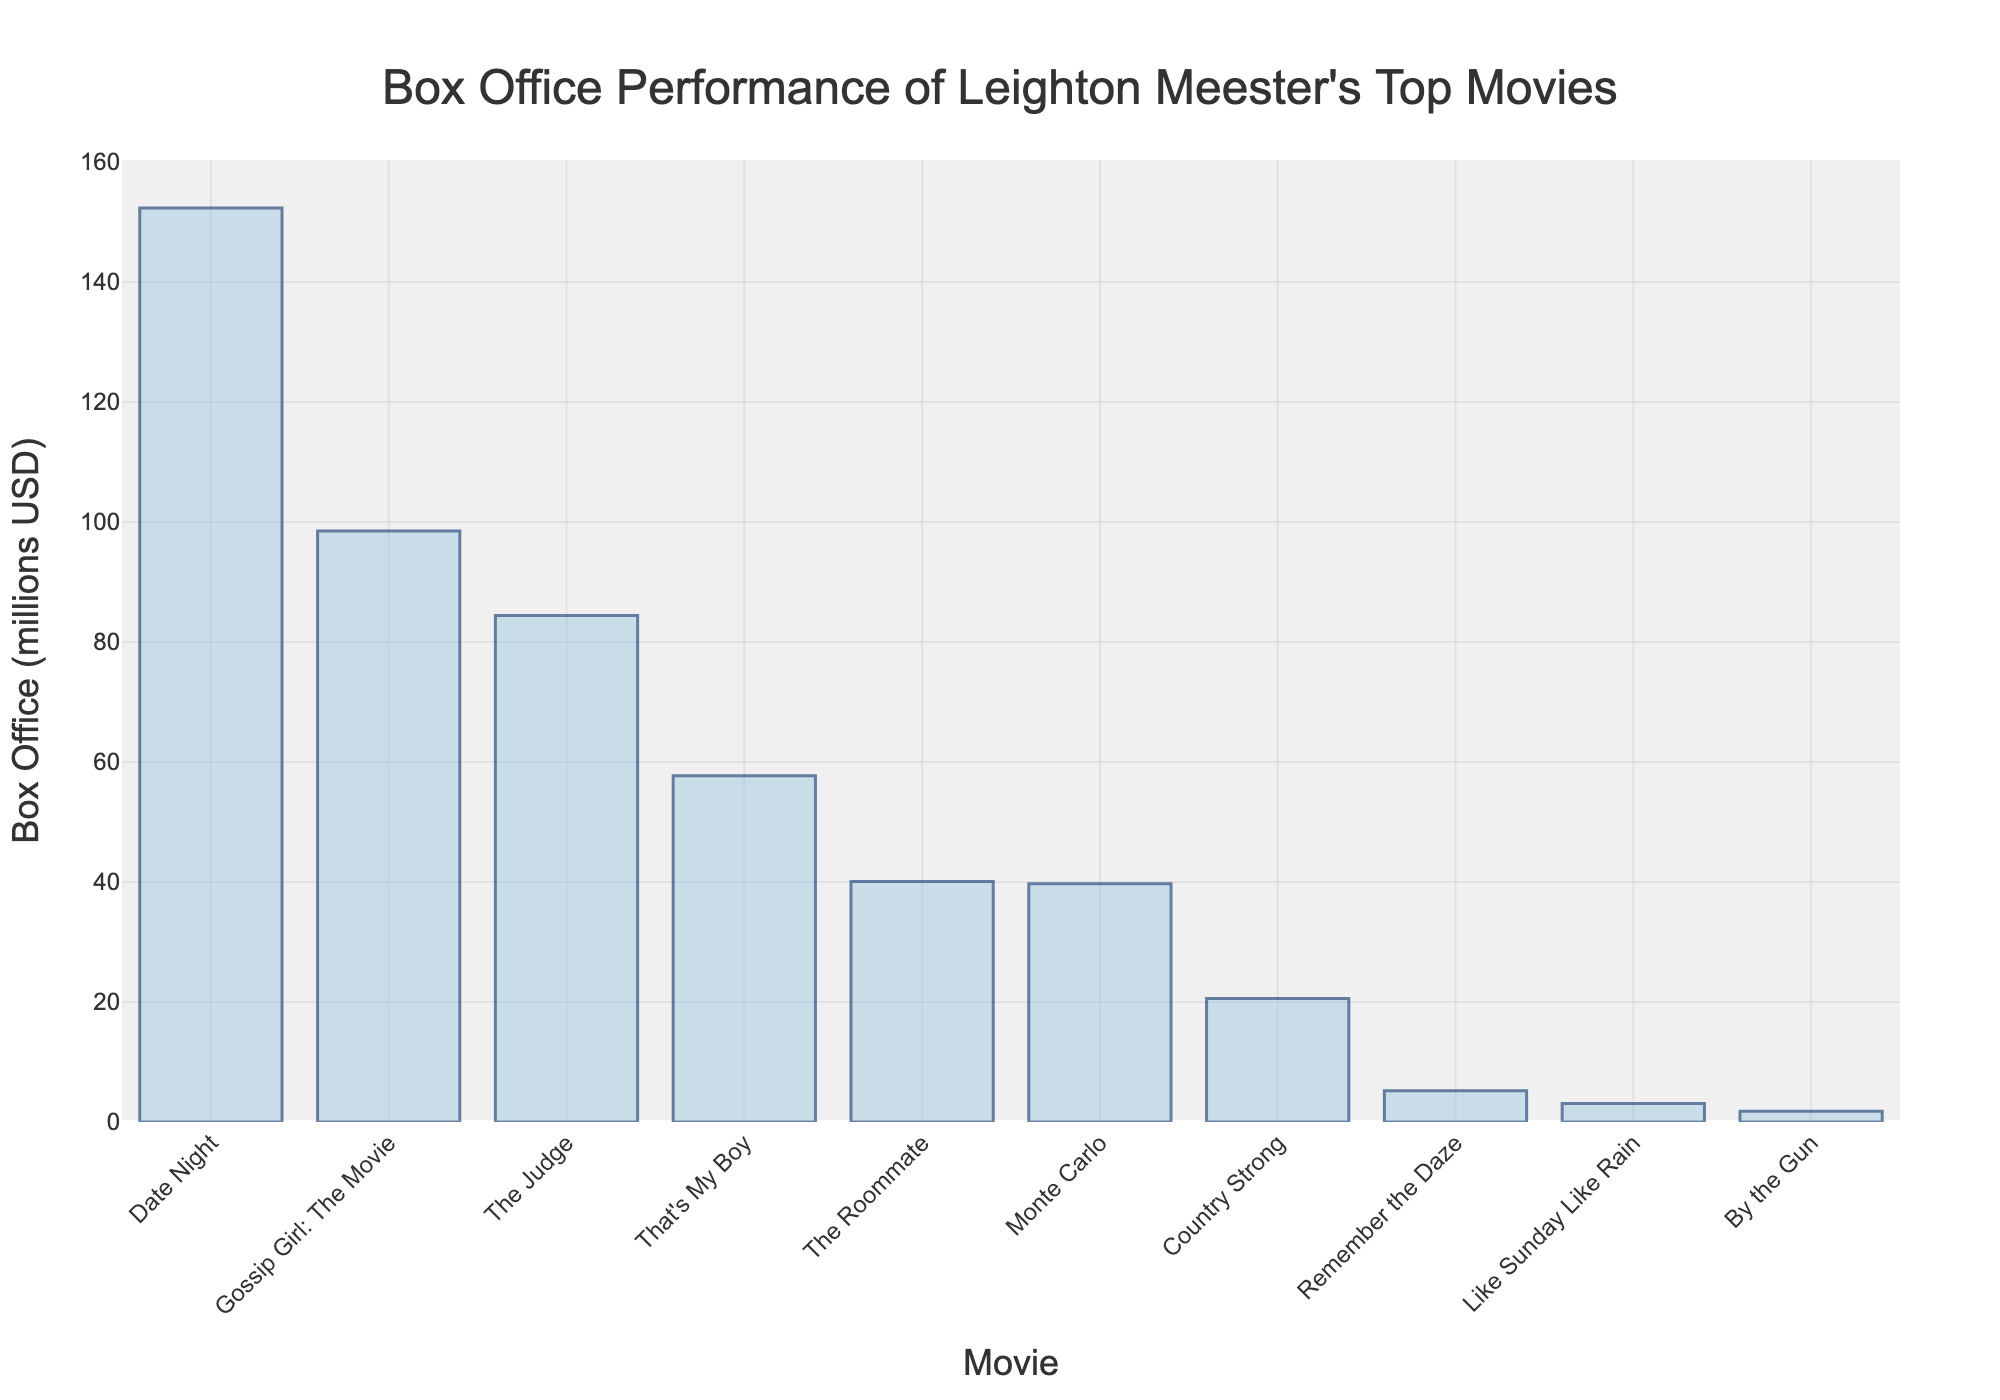What's the highest-grossing movie? To find the highest-grossing movie, look for the tallest bar in the graph. The tallest bar represents "Date Night" with a box office of $152.3 million.
Answer: Date Night Which movie had the lowest box office performance? To identify the movie with the lowest box office performance, find the shortest bar in the graph. The shortest bar represents "By the Gun" with a box office of $1.8 million.
Answer: By the Gun What is the combined box office performance of "Gossip Girl: The Movie" and "The Judge"? Add the box office revenues of "Gossip Girl: The Movie" (98.5 million) and "The Judge" (84.4 million). The sum is 98.5 + 84.4 = 182.9 million.
Answer: 182.9 million How many movies have box office performances above $50 million? Count the number of bars that have a height representing box office revenues above $50 million. These movies are "Date Night," "Gossip Girl: The Movie," and "That's My Boy," so the count is 3.
Answer: 3 Which movie had a box office performance closest to $40 million? Look for the bar closest to the $40 million mark. "The Roommate" with $40.1 million and "Monte Carlo" with $39.7 million are close, but "Monte Carlo" is closest to $40 million.
Answer: Monte Carlo What is the difference in box office performance between "Country Strong" and "Remember the Daze"? Subtract the box office revenue of "Remember the Daze" ($5.2 million) from "Country Strong" ($20.6 million). Thus, 20.6 - 5.2 = 15.4 million.
Answer: 15.4 million Which movie had a better box office performance: "Monte Carlo" or "The Roommate"? Compare the heights of the bars for "Monte Carlo" ($39.7 million) and "The Roommate" ($40.1 million). "The Roommate" had a slightly better performance.
Answer: The Roommate What is the average box office performance of the top five movies? Add the revenues of the top five movies: $152.3 million (Date Night), $98.5 million (Gossip Girl: The Movie), $84.4 million (The Judge), $57.7 million (That's My Boy), and $40.1 million (The Roommate), then divide by 5. The sum is 152.3 + 98.5 + 84.4 + 57.7 + 40.1 = 432. To find the average, divide 432 by 5, which gives 432 / 5 = 86.4 million.
Answer: 86.4 million 